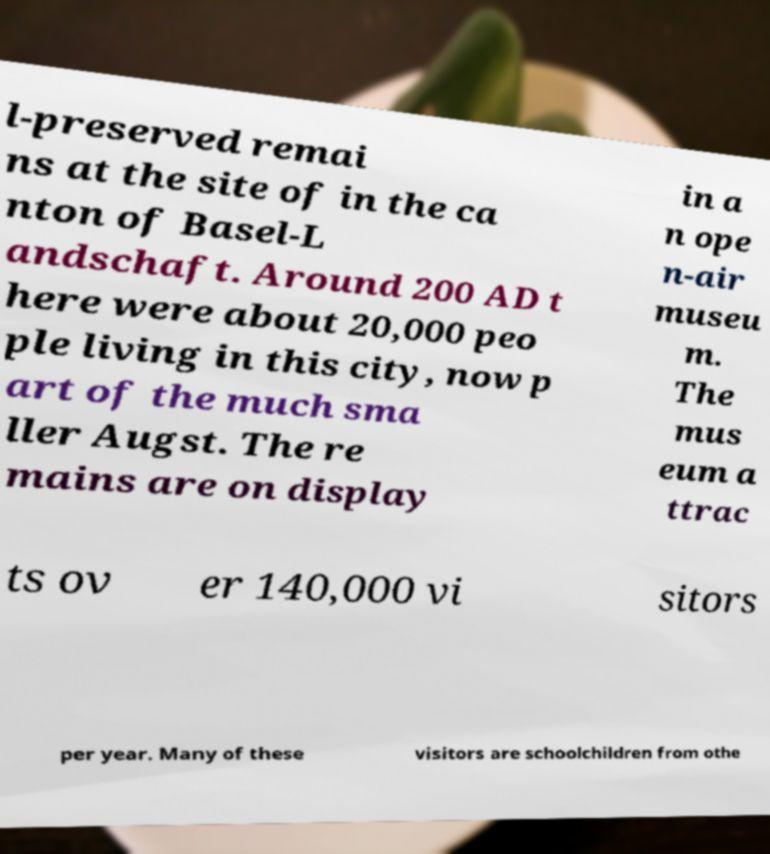For documentation purposes, I need the text within this image transcribed. Could you provide that? l-preserved remai ns at the site of in the ca nton of Basel-L andschaft. Around 200 AD t here were about 20,000 peo ple living in this city, now p art of the much sma ller Augst. The re mains are on display in a n ope n-air museu m. The mus eum a ttrac ts ov er 140,000 vi sitors per year. Many of these visitors are schoolchildren from othe 